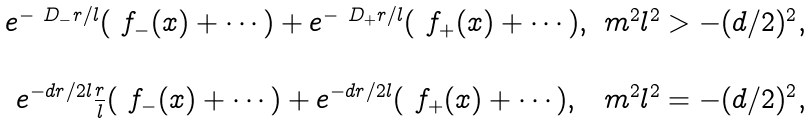<formula> <loc_0><loc_0><loc_500><loc_500>\begin{matrix} e ^ { - \ D _ { - } r / l } ( \ f _ { - } ( x ) + \cdots ) + e ^ { - \ D _ { + } r / l } ( \ f _ { + } ( x ) + \cdots ) , & m ^ { 2 } l ^ { 2 } > - ( d / 2 ) ^ { 2 } , \\ \\ e ^ { - d r / 2 l } \frac { r } { l } ( \ f _ { - } ( x ) + \cdots ) + e ^ { - d r / 2 l } ( \ f _ { + } ( x ) + \cdots ) , & m ^ { 2 } l ^ { 2 } = - ( d / 2 ) ^ { 2 } , \\ \end{matrix}</formula> 